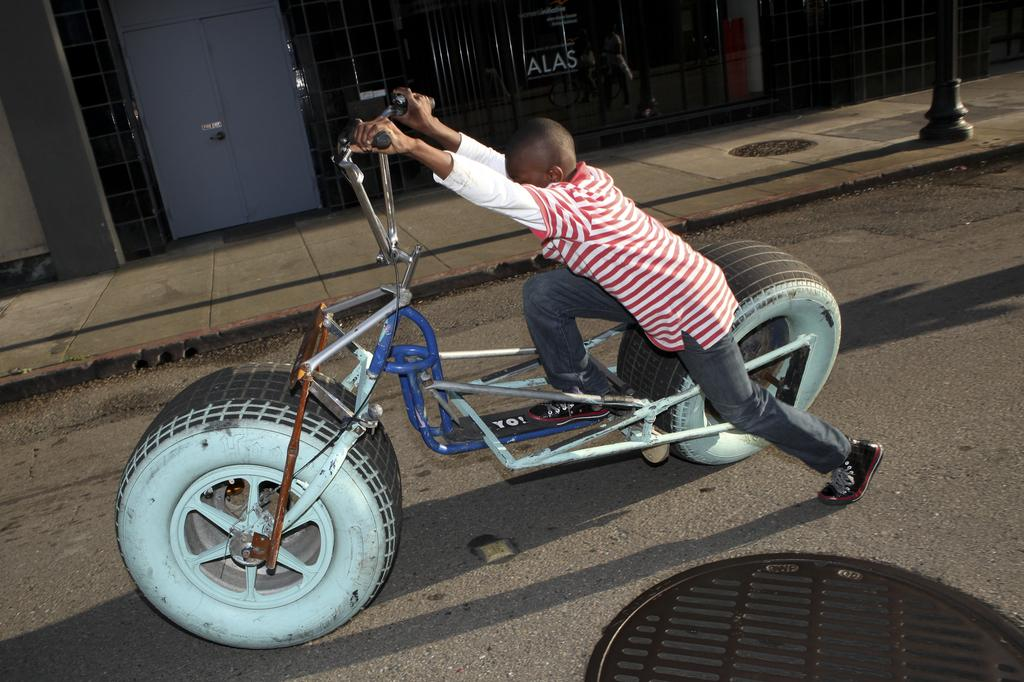Who is the main subject in the image? There is a boy in the image. What is the boy doing in the image? The boy is riding a motorcycle. Where is the motorcycle located in the image? The motorcycle is on the road. What type of skirt is the boy wearing in the image? The boy is not wearing a skirt in the image; he is riding a motorcycle. 